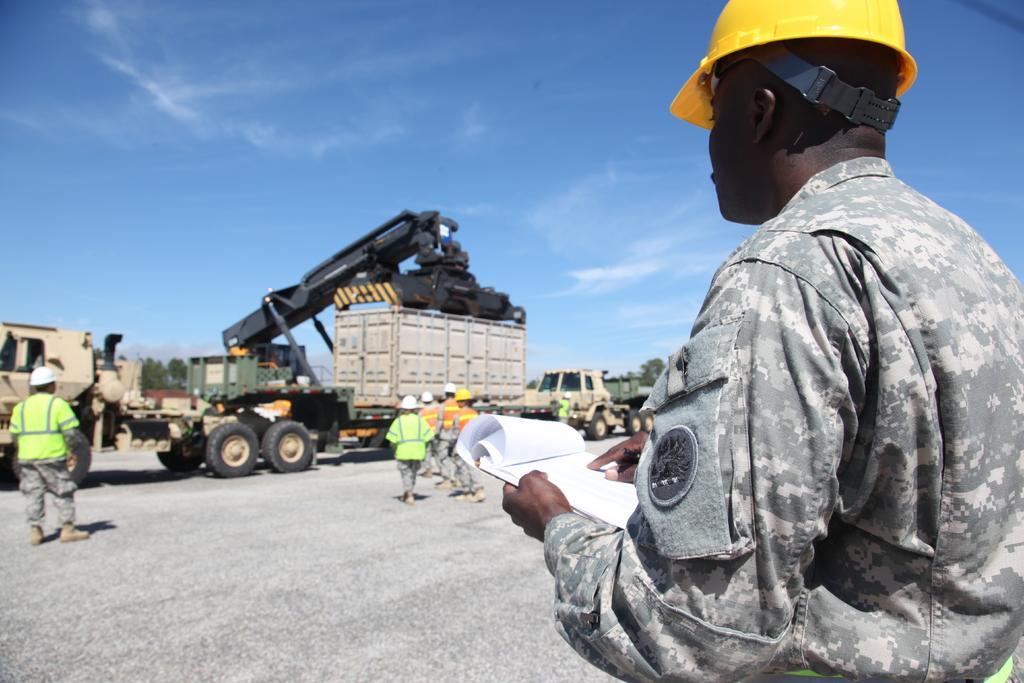Could you give a brief overview of what you see in this image? In the image there is a man in camouflage dress and yellow helmet standing on the right side with a book in his hand, in the back there are trucks with containers on it and few people standing in front of it and above its sky. 